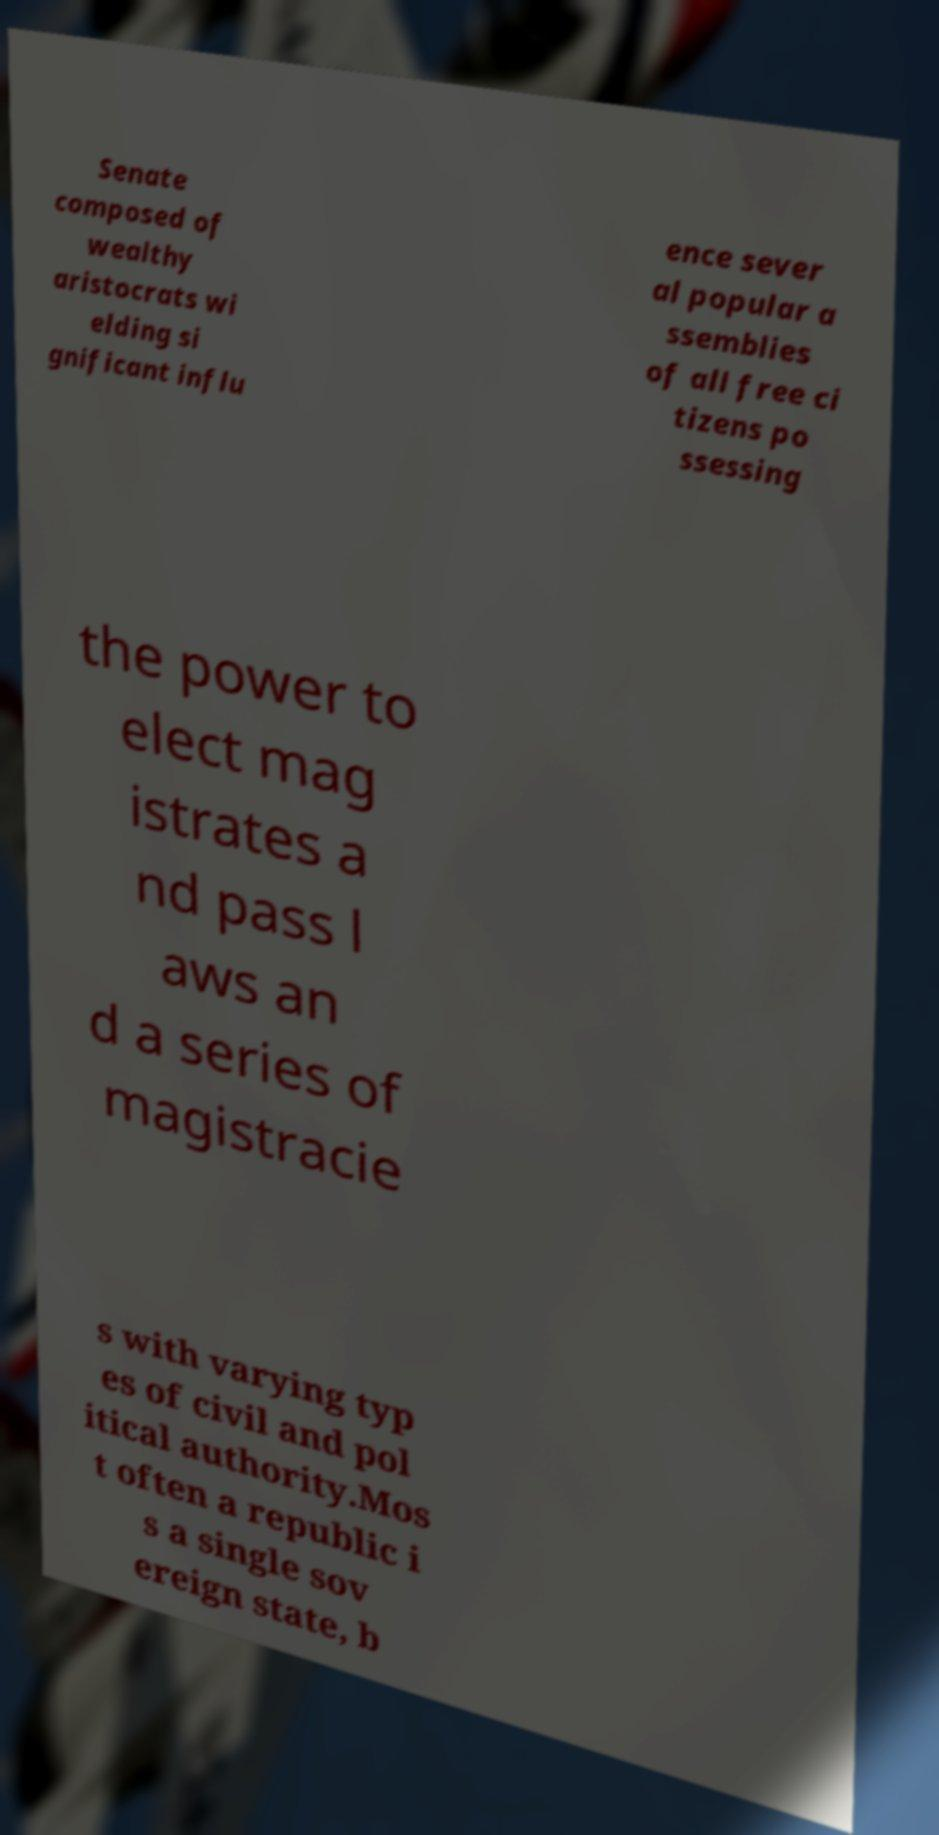Can you read and provide the text displayed in the image?This photo seems to have some interesting text. Can you extract and type it out for me? Senate composed of wealthy aristocrats wi elding si gnificant influ ence sever al popular a ssemblies of all free ci tizens po ssessing the power to elect mag istrates a nd pass l aws an d a series of magistracie s with varying typ es of civil and pol itical authority.Mos t often a republic i s a single sov ereign state, b 